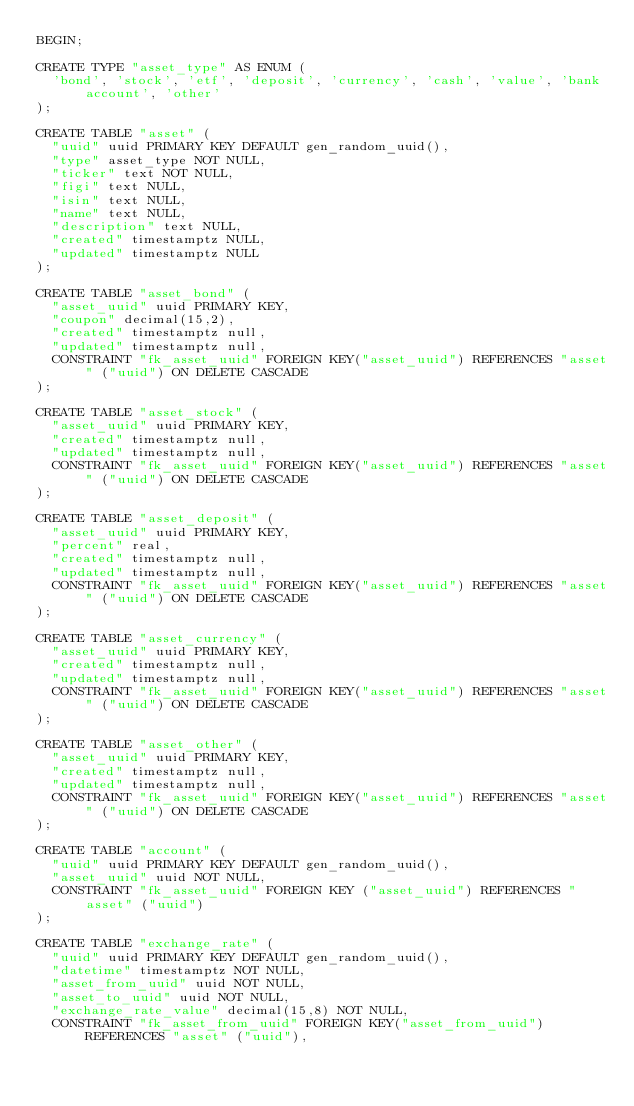Convert code to text. <code><loc_0><loc_0><loc_500><loc_500><_SQL_>BEGIN;

CREATE TYPE "asset_type" AS ENUM (
  'bond', 'stock', 'etf', 'deposit', 'currency', 'cash', 'value', 'bank account', 'other'
);

CREATE TABLE "asset" (
  "uuid" uuid PRIMARY KEY DEFAULT gen_random_uuid(),
  "type" asset_type NOT NULL,
  "ticker" text NOT NULL,
  "figi" text NULL,
  "isin" text NULL,
  "name" text NULL,
  "description" text NULL,
  "created" timestamptz NULL,
  "updated" timestamptz NULL
);

CREATE TABLE "asset_bond" (
  "asset_uuid" uuid PRIMARY KEY,
  "coupon" decimal(15,2),
  "created" timestamptz null,
  "updated" timestamptz null,
  CONSTRAINT "fk_asset_uuid" FOREIGN KEY("asset_uuid") REFERENCES "asset" ("uuid") ON DELETE CASCADE
);

CREATE TABLE "asset_stock" (
  "asset_uuid" uuid PRIMARY KEY,
  "created" timestamptz null,
  "updated" timestamptz null,
  CONSTRAINT "fk_asset_uuid" FOREIGN KEY("asset_uuid") REFERENCES "asset" ("uuid") ON DELETE CASCADE
);

CREATE TABLE "asset_deposit" (
  "asset_uuid" uuid PRIMARY KEY,
  "percent" real,
  "created" timestamptz null,
  "updated" timestamptz null,
  CONSTRAINT "fk_asset_uuid" FOREIGN KEY("asset_uuid") REFERENCES "asset" ("uuid") ON DELETE CASCADE
);

CREATE TABLE "asset_currency" (
  "asset_uuid" uuid PRIMARY KEY,
  "created" timestamptz null,
  "updated" timestamptz null,
  CONSTRAINT "fk_asset_uuid" FOREIGN KEY("asset_uuid") REFERENCES "asset" ("uuid") ON DELETE CASCADE
);

CREATE TABLE "asset_other" (
  "asset_uuid" uuid PRIMARY KEY,
  "created" timestamptz null,
  "updated" timestamptz null,
  CONSTRAINT "fk_asset_uuid" FOREIGN KEY("asset_uuid") REFERENCES "asset" ("uuid") ON DELETE CASCADE
);

CREATE TABLE "account" (
  "uuid" uuid PRIMARY KEY DEFAULT gen_random_uuid(),
  "asset_uuid" uuid NOT NULL,
  CONSTRAINT "fk_asset_uuid" FOREIGN KEY ("asset_uuid") REFERENCES "asset" ("uuid")
);

CREATE TABLE "exchange_rate" (
  "uuid" uuid PRIMARY KEY DEFAULT gen_random_uuid(),
  "datetime" timestamptz NOT NULL,
  "asset_from_uuid" uuid NOT NULL,
  "asset_to_uuid" uuid NOT NULL,
  "exchange_rate_value" decimal(15,8) NOT NULL,
  CONSTRAINT "fk_asset_from_uuid" FOREIGN KEY("asset_from_uuid") REFERENCES "asset" ("uuid"),</code> 